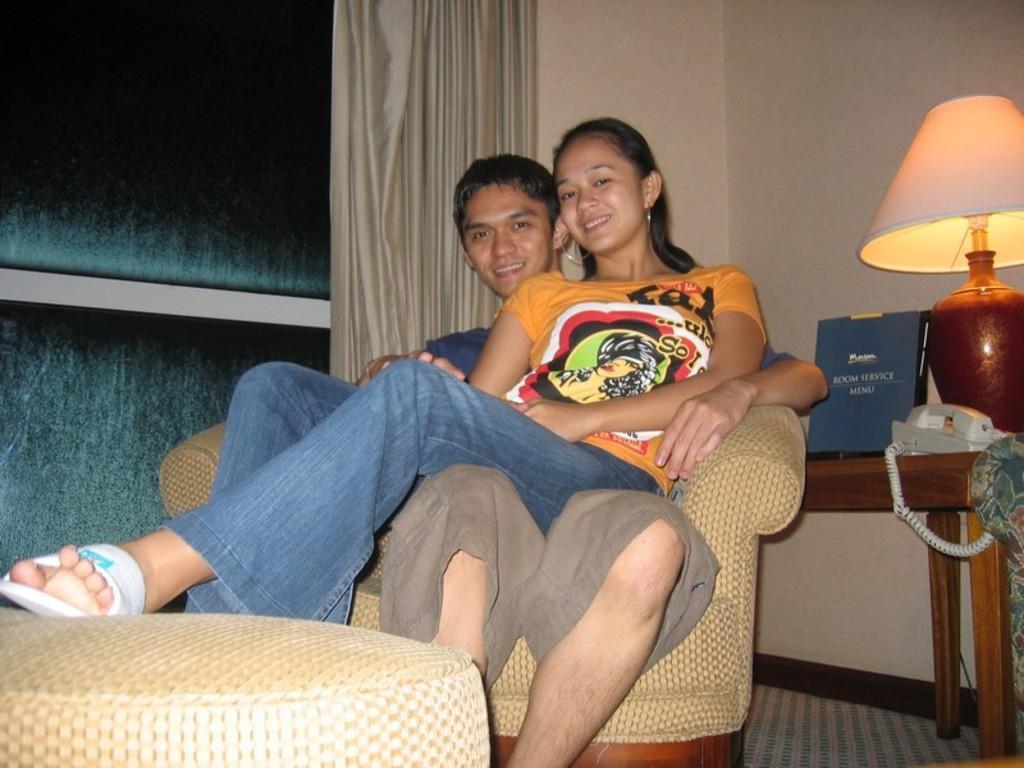In one or two sentences, can you explain what this image depicts? in this image we can see two persons sitting in a chair. One woman is wearing an orange shirt. To the left side of the image we can see a stool. To the right side of the image we can see a telephone, table lamp and a card placed on the table. In the background we can see the curtains. 